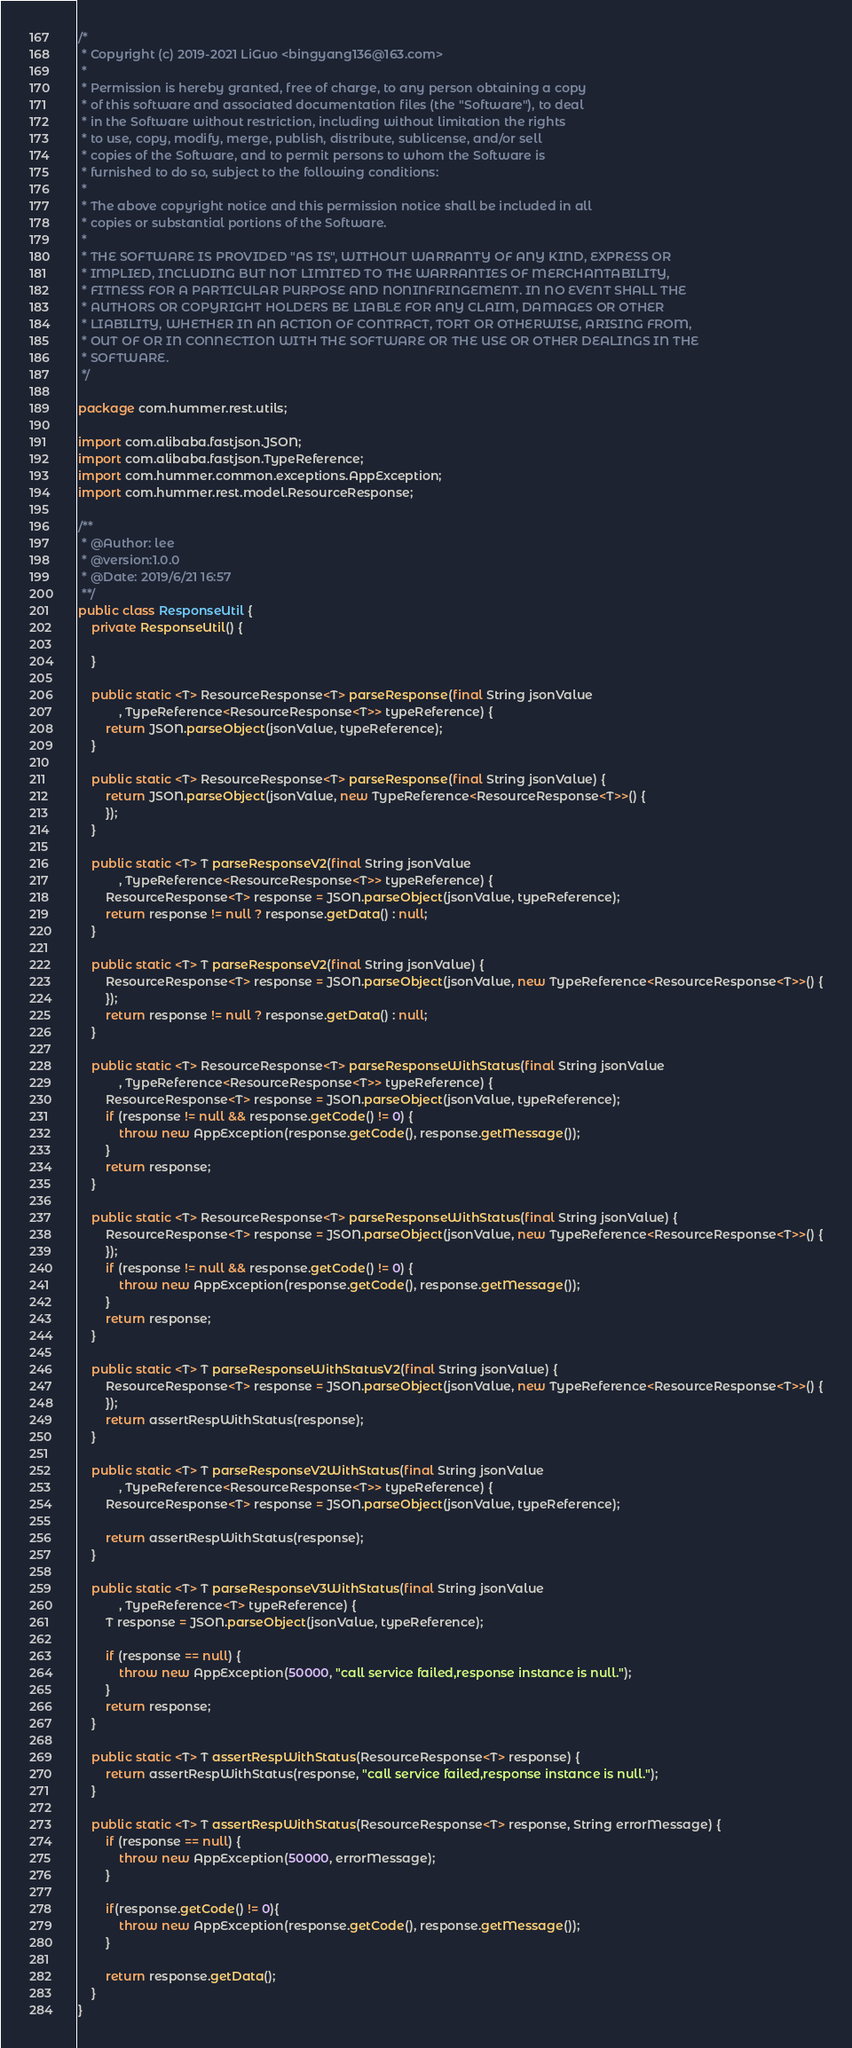Convert code to text. <code><loc_0><loc_0><loc_500><loc_500><_Java_>/*
 * Copyright (c) 2019-2021 LiGuo <bingyang136@163.com>
 *
 * Permission is hereby granted, free of charge, to any person obtaining a copy
 * of this software and associated documentation files (the "Software"), to deal
 * in the Software without restriction, including without limitation the rights
 * to use, copy, modify, merge, publish, distribute, sublicense, and/or sell
 * copies of the Software, and to permit persons to whom the Software is
 * furnished to do so, subject to the following conditions:
 *
 * The above copyright notice and this permission notice shall be included in all
 * copies or substantial portions of the Software.
 *
 * THE SOFTWARE IS PROVIDED "AS IS", WITHOUT WARRANTY OF ANY KIND, EXPRESS OR
 * IMPLIED, INCLUDING BUT NOT LIMITED TO THE WARRANTIES OF MERCHANTABILITY,
 * FITNESS FOR A PARTICULAR PURPOSE AND NONINFRINGEMENT. IN NO EVENT SHALL THE
 * AUTHORS OR COPYRIGHT HOLDERS BE LIABLE FOR ANY CLAIM, DAMAGES OR OTHER
 * LIABILITY, WHETHER IN AN ACTION OF CONTRACT, TORT OR OTHERWISE, ARISING FROM,
 * OUT OF OR IN CONNECTION WITH THE SOFTWARE OR THE USE OR OTHER DEALINGS IN THE
 * SOFTWARE.
 */

package com.hummer.rest.utils;

import com.alibaba.fastjson.JSON;
import com.alibaba.fastjson.TypeReference;
import com.hummer.common.exceptions.AppException;
import com.hummer.rest.model.ResourceResponse;

/**
 * @Author: lee
 * @version:1.0.0
 * @Date: 2019/6/21 16:57
 **/
public class ResponseUtil {
    private ResponseUtil() {

    }

    public static <T> ResourceResponse<T> parseResponse(final String jsonValue
            , TypeReference<ResourceResponse<T>> typeReference) {
        return JSON.parseObject(jsonValue, typeReference);
    }

    public static <T> ResourceResponse<T> parseResponse(final String jsonValue) {
        return JSON.parseObject(jsonValue, new TypeReference<ResourceResponse<T>>() {
        });
    }

    public static <T> T parseResponseV2(final String jsonValue
            , TypeReference<ResourceResponse<T>> typeReference) {
        ResourceResponse<T> response = JSON.parseObject(jsonValue, typeReference);
        return response != null ? response.getData() : null;
    }

    public static <T> T parseResponseV2(final String jsonValue) {
        ResourceResponse<T> response = JSON.parseObject(jsonValue, new TypeReference<ResourceResponse<T>>() {
        });
        return response != null ? response.getData() : null;
    }

    public static <T> ResourceResponse<T> parseResponseWithStatus(final String jsonValue
            , TypeReference<ResourceResponse<T>> typeReference) {
        ResourceResponse<T> response = JSON.parseObject(jsonValue, typeReference);
        if (response != null && response.getCode() != 0) {
            throw new AppException(response.getCode(), response.getMessage());
        }
        return response;
    }

    public static <T> ResourceResponse<T> parseResponseWithStatus(final String jsonValue) {
        ResourceResponse<T> response = JSON.parseObject(jsonValue, new TypeReference<ResourceResponse<T>>() {
        });
        if (response != null && response.getCode() != 0) {
            throw new AppException(response.getCode(), response.getMessage());
        }
        return response;
    }

    public static <T> T parseResponseWithStatusV2(final String jsonValue) {
        ResourceResponse<T> response = JSON.parseObject(jsonValue, new TypeReference<ResourceResponse<T>>() {
        });
        return assertRespWithStatus(response);
    }

    public static <T> T parseResponseV2WithStatus(final String jsonValue
            , TypeReference<ResourceResponse<T>> typeReference) {
        ResourceResponse<T> response = JSON.parseObject(jsonValue, typeReference);

        return assertRespWithStatus(response);
    }

    public static <T> T parseResponseV3WithStatus(final String jsonValue
            , TypeReference<T> typeReference) {
        T response = JSON.parseObject(jsonValue, typeReference);

        if (response == null) {
            throw new AppException(50000, "call service failed,response instance is null.");
        }
        return response;
    }

    public static <T> T assertRespWithStatus(ResourceResponse<T> response) {
        return assertRespWithStatus(response, "call service failed,response instance is null.");
    }

    public static <T> T assertRespWithStatus(ResourceResponse<T> response, String errorMessage) {
        if (response == null) {
            throw new AppException(50000, errorMessage);
        }

        if(response.getCode() != 0){
            throw new AppException(response.getCode(), response.getMessage());
        }

        return response.getData();
    }
}
</code> 